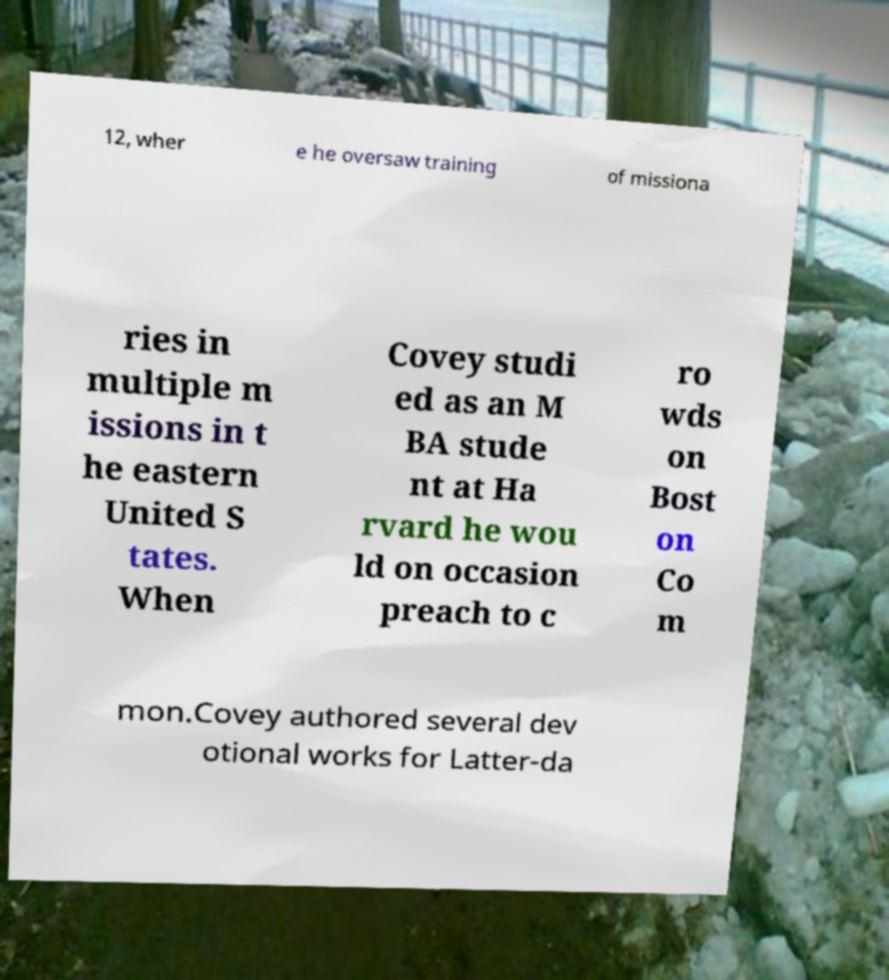Please identify and transcribe the text found in this image. 12, wher e he oversaw training of missiona ries in multiple m issions in t he eastern United S tates. When Covey studi ed as an M BA stude nt at Ha rvard he wou ld on occasion preach to c ro wds on Bost on Co m mon.Covey authored several dev otional works for Latter-da 